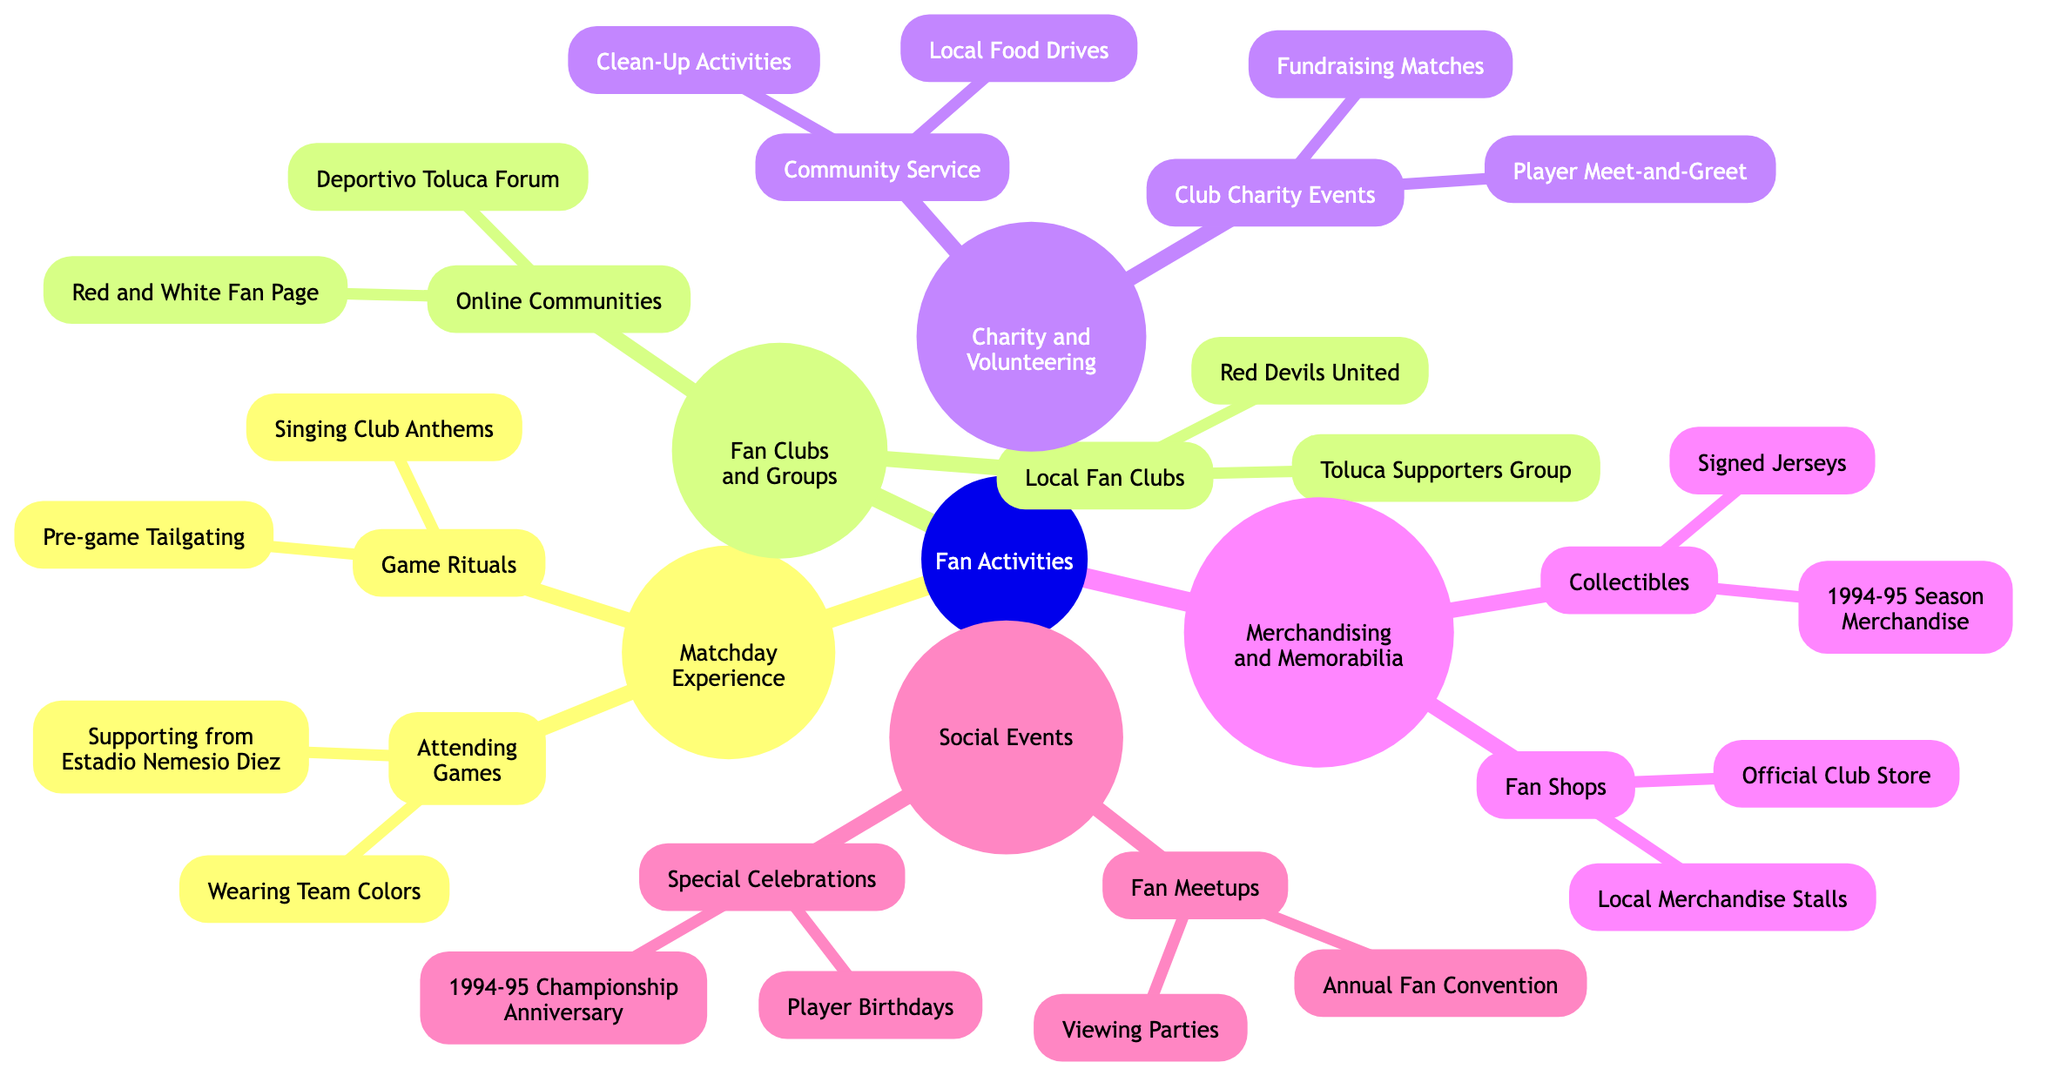What are two activities listed under Matchday Experience? The "Matchday Experience" branch includes two categories: "Attending Games" and "Game Rituals". Under "Attending Games", two activities are listed: "Supporting from Estadio Nemesio Diez" and "Wearing Team Colors".
Answer: Supporting from Estadio Nemesio Diez, Wearing Team Colors How many local fan clubs are mentioned? Under the "Fan Clubs and Groups" category, there are two subcategories: "Local Fan Clubs" and "Online Communities". The "Local Fan Clubs" subcategory lists two clubs: "Red Devils United" and "Toluca Supporters Group". Therefore, the number of local fan clubs mentioned is 2.
Answer: 2 What type of community service is included? The "Charity and Volunteering" branch has a subcategory titled "Community Service", which includes "Local Food Drives" and "Clean-Up Activities". This indicates that community service activities involve these two specific actions.
Answer: Local Food Drives, Clean-Up Activities How many different types of social events are listed? In the "Social Events" category, there are two main types: "Fan Meetups" and "Special Celebrations". Each type further lists two distinct events. Thus, there are 2 main types of social events.
Answer: 2 Which category includes the 1994-95 season merchandise? The "Merchandising and Memorabilia" category includes a subcategory called "Collectibles" where the "1994-95 Season Merchandise" is specifically mentioned. This indicates that the 1994-95 season merchandise falls under merchandise and memorabilia.
Answer: Merchandising and Memorabilia What includes the anniversary celebration of the 1994-95 championship? The anniversary of the 1994-95 championship is explicitly mentioned under the "Special Celebrations" subcategory within "Social Events". This means that this specific celebration falls under social events aimed at commemorating the team's history.
Answer: Special Celebrations What is a type of event under Club Charity Events? The "Club Charity Events" section includes either "Fundraising Matches" or "Player Meet-and-Greet for Charity" as its activities. Either of these is a valid answer to the type of event listed under this category.
Answer: Fundraising Matches, Player Meet-and-Greet for Charity 